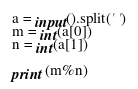<code> <loc_0><loc_0><loc_500><loc_500><_Python_>a = input().split(' ')
m = int(a[0])
n = int(a[1])

print (m%n)</code> 